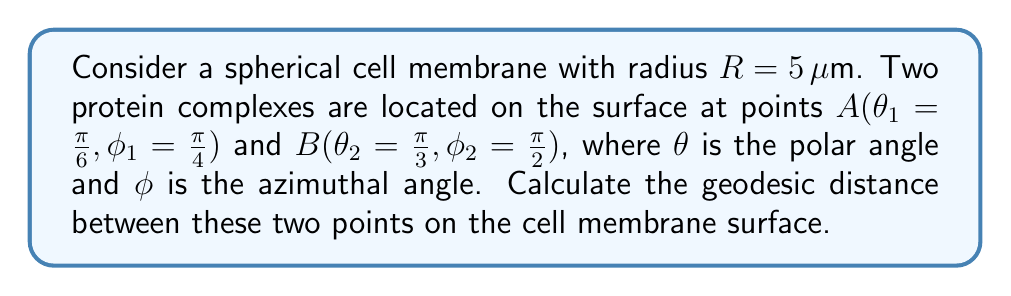Can you solve this math problem? To calculate the geodesic distance between two points on a spherical surface, we can use the spherical law of cosines. The steps are as follows:

1. The spherical law of cosines states:
   $$\cos(c) = \sin(\theta_1)\sin(\theta_2)\cos(\phi_2 - \phi_1) + \cos(\theta_1)\cos(\theta_2)$$
   where $c$ is the central angle between the two points.

2. Let's substitute the given values:
   $\theta_1 = \frac{\pi}{6}$, $\phi_1 = \frac{\pi}{4}$
   $\theta_2 = \frac{\pi}{3}$, $\phi_2 = \frac{\pi}{2}$

3. Calculate $\cos(c)$:
   $$\cos(c) = \sin(\frac{\pi}{6})\sin(\frac{\pi}{3})\cos(\frac{\pi}{2} - \frac{\pi}{4}) + \cos(\frac{\pi}{6})\cos(\frac{\pi}{3})$$

4. Simplify:
   $$\cos(c) = (\frac{1}{2})(\frac{\sqrt{3}}{2})(\frac{\sqrt{2}}{2}) + (\frac{\sqrt{3}}{2})(\frac{1}{2})$$
   $$\cos(c) = \frac{\sqrt{6}}{8} + \frac{\sqrt{3}}{4} = \frac{\sqrt{6} + \sqrt{12}}{8}$$

5. Take the arccos of both sides to find $c$:
   $$c = \arccos(\frac{\sqrt{6} + \sqrt{12}}{8})$$

6. The geodesic distance $d$ on a sphere is given by:
   $$d = R \cdot c$$

7. Substitute $R = 5 \mu m$ and the value of $c$:
   $$d = 5 \cdot \arccos(\frac{\sqrt{6} + \sqrt{12}}{8})$$

8. Calculate the final result:
   $$d \approx 2.62 \mu m$$
Answer: $2.62 \mu m$ 